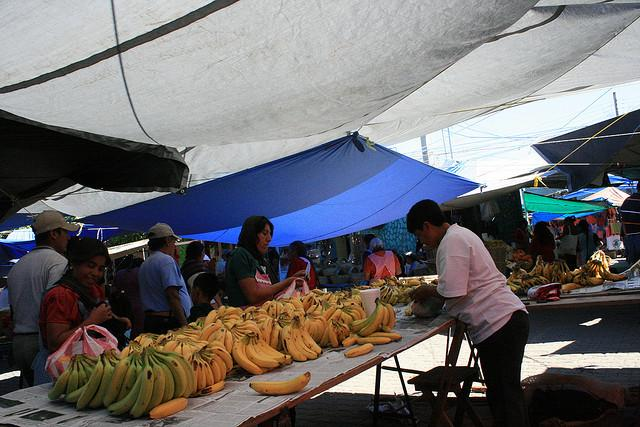Encouraging what American Ice cream treat is an obvious choice for these vendors? Please explain your reasoning. banana split. Banana splits can be made. 